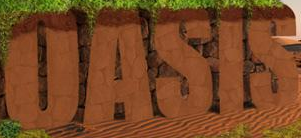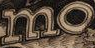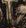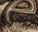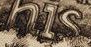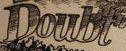Identify the words shown in these images in order, separated by a semicolon. OASIS; mo; #; e; his; Doubt 